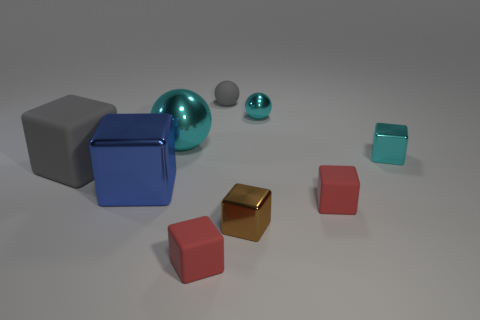What materials do the objects in the image appear to be made of? The objects in the image seem to be made of different materials. The large and small spheres have a shiny, reflective surface that suggests they could be made of a polished metal or a similar material. The cubes appear to have a matte finish, possibly indicating they are made of plastic, metal, or coated materials. The distinct textures and light reflections give cues about their material composition. 